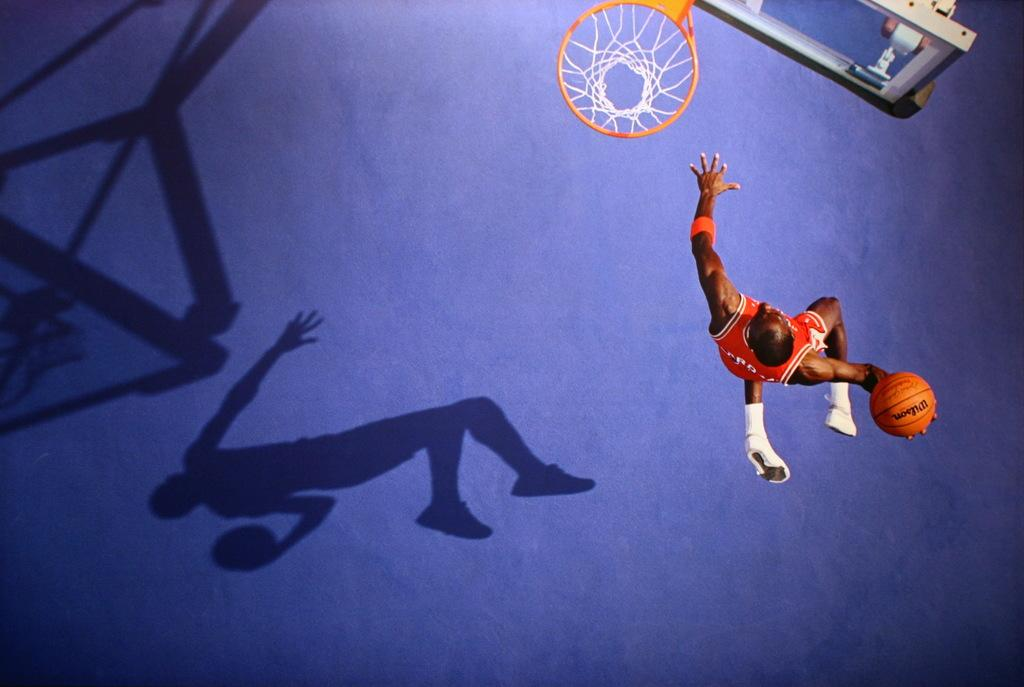Who is present in the image? There is a man in the image. What is the man doing in the image? The man is jumping in the image. What is the man holding in the image? The man is holding a ball in the image. What can be seen in the background of the image? There is a basketball hoop in the image. Are there any shadows visible in the image? Yes, there is a shadow of a person and a shadow of a basketball hoop visible in the image. What type of connection can be seen between the man and the basketball hoop in the image? There is no visible connection between the man and the basketball hoop in the image; they are separate objects. What emotion is the man expressing towards the basketball hoop in the image? The image does not show any clear expression of emotion, so it cannot be determined if the man is expressing hate or any other emotion towards the basketball hoop. 